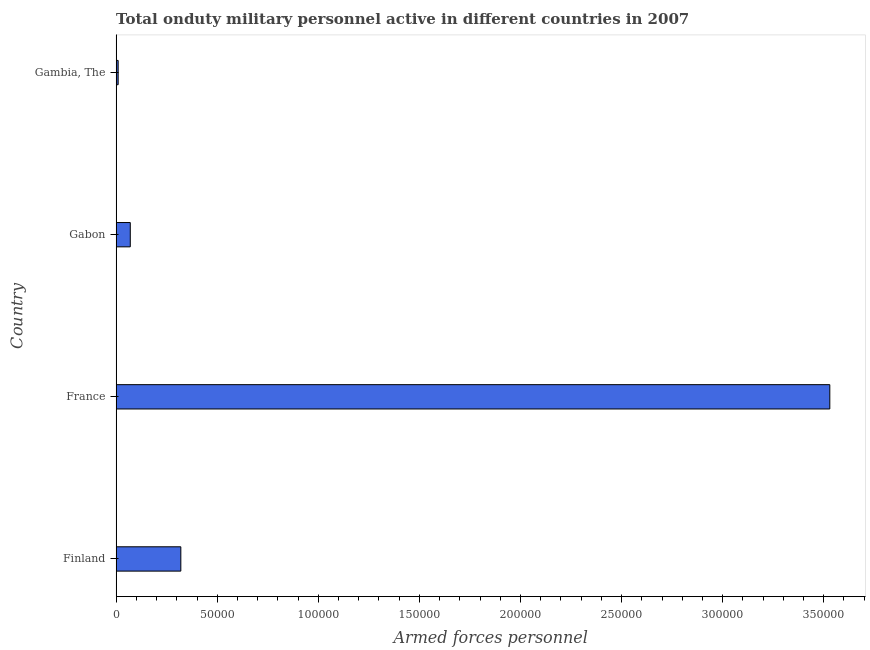Does the graph contain grids?
Your answer should be very brief. No. What is the title of the graph?
Provide a succinct answer. Total onduty military personnel active in different countries in 2007. What is the label or title of the X-axis?
Make the answer very short. Armed forces personnel. What is the label or title of the Y-axis?
Your answer should be compact. Country. What is the number of armed forces personnel in Gabon?
Provide a succinct answer. 7000. Across all countries, what is the maximum number of armed forces personnel?
Keep it short and to the point. 3.53e+05. In which country was the number of armed forces personnel minimum?
Provide a succinct answer. Gambia, The. What is the sum of the number of armed forces personnel?
Your answer should be very brief. 3.93e+05. What is the difference between the number of armed forces personnel in France and Gambia, The?
Offer a very short reply. 3.52e+05. What is the average number of armed forces personnel per country?
Offer a terse response. 9.82e+04. What is the median number of armed forces personnel?
Make the answer very short. 1.95e+04. What is the ratio of the number of armed forces personnel in Finland to that in Gabon?
Keep it short and to the point. 4.57. What is the difference between the highest and the second highest number of armed forces personnel?
Make the answer very short. 3.21e+05. Is the sum of the number of armed forces personnel in France and Gambia, The greater than the maximum number of armed forces personnel across all countries?
Ensure brevity in your answer.  Yes. What is the difference between the highest and the lowest number of armed forces personnel?
Your answer should be very brief. 3.52e+05. Are all the bars in the graph horizontal?
Your answer should be very brief. Yes. What is the Armed forces personnel of Finland?
Keep it short and to the point. 3.20e+04. What is the Armed forces personnel in France?
Your answer should be very brief. 3.53e+05. What is the Armed forces personnel in Gabon?
Your answer should be very brief. 7000. What is the Armed forces personnel in Gambia, The?
Keep it short and to the point. 1000. What is the difference between the Armed forces personnel in Finland and France?
Your answer should be compact. -3.21e+05. What is the difference between the Armed forces personnel in Finland and Gabon?
Your response must be concise. 2.50e+04. What is the difference between the Armed forces personnel in Finland and Gambia, The?
Ensure brevity in your answer.  3.10e+04. What is the difference between the Armed forces personnel in France and Gabon?
Offer a very short reply. 3.46e+05. What is the difference between the Armed forces personnel in France and Gambia, The?
Your response must be concise. 3.52e+05. What is the difference between the Armed forces personnel in Gabon and Gambia, The?
Your response must be concise. 6000. What is the ratio of the Armed forces personnel in Finland to that in France?
Offer a very short reply. 0.09. What is the ratio of the Armed forces personnel in Finland to that in Gabon?
Ensure brevity in your answer.  4.57. What is the ratio of the Armed forces personnel in France to that in Gabon?
Your response must be concise. 50.43. What is the ratio of the Armed forces personnel in France to that in Gambia, The?
Make the answer very short. 353. 